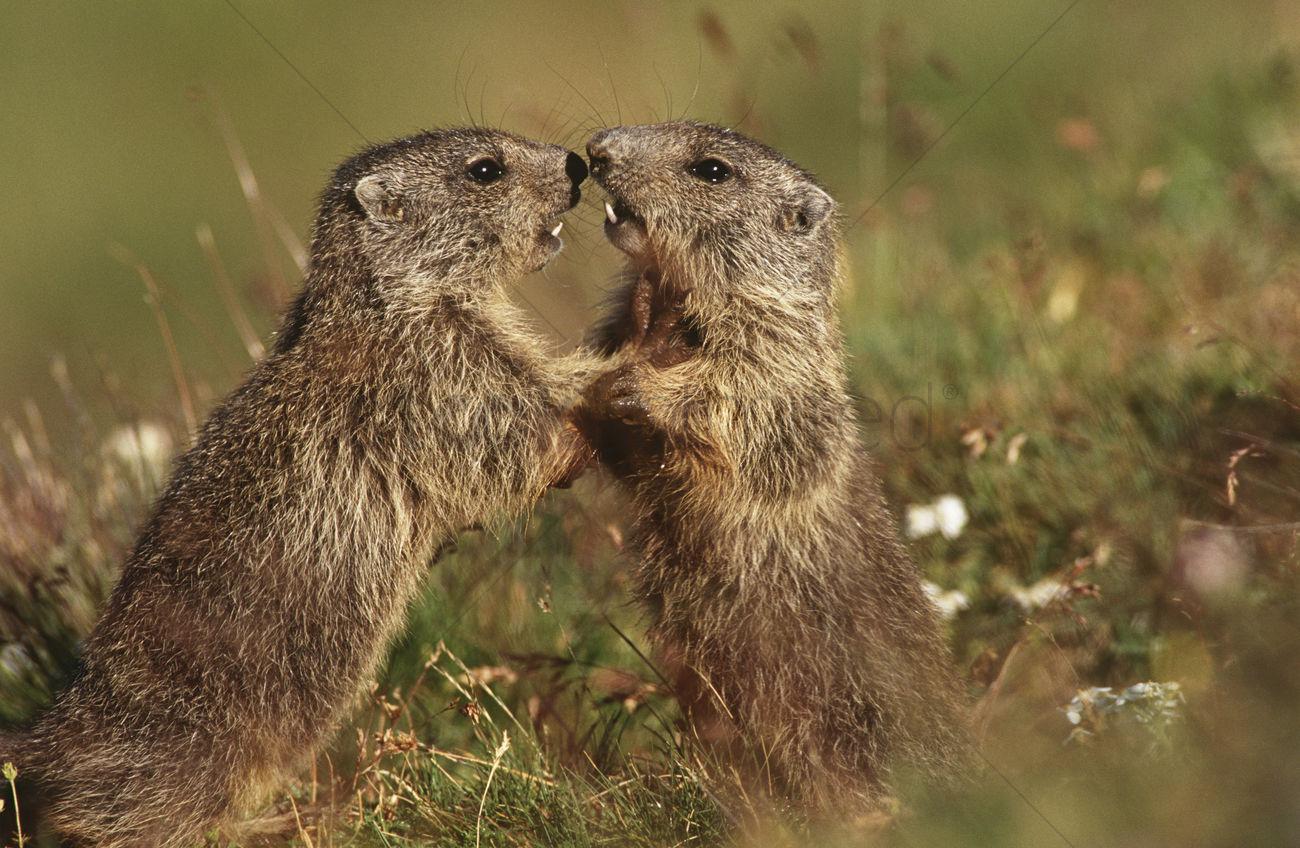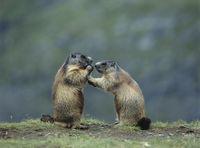The first image is the image on the left, the second image is the image on the right. Evaluate the accuracy of this statement regarding the images: "The marmots are touching in each image.". Is it true? Answer yes or no. Yes. The first image is the image on the left, the second image is the image on the right. Considering the images on both sides, is "Two pairs of ground hogs are kissing." valid? Answer yes or no. Yes. 